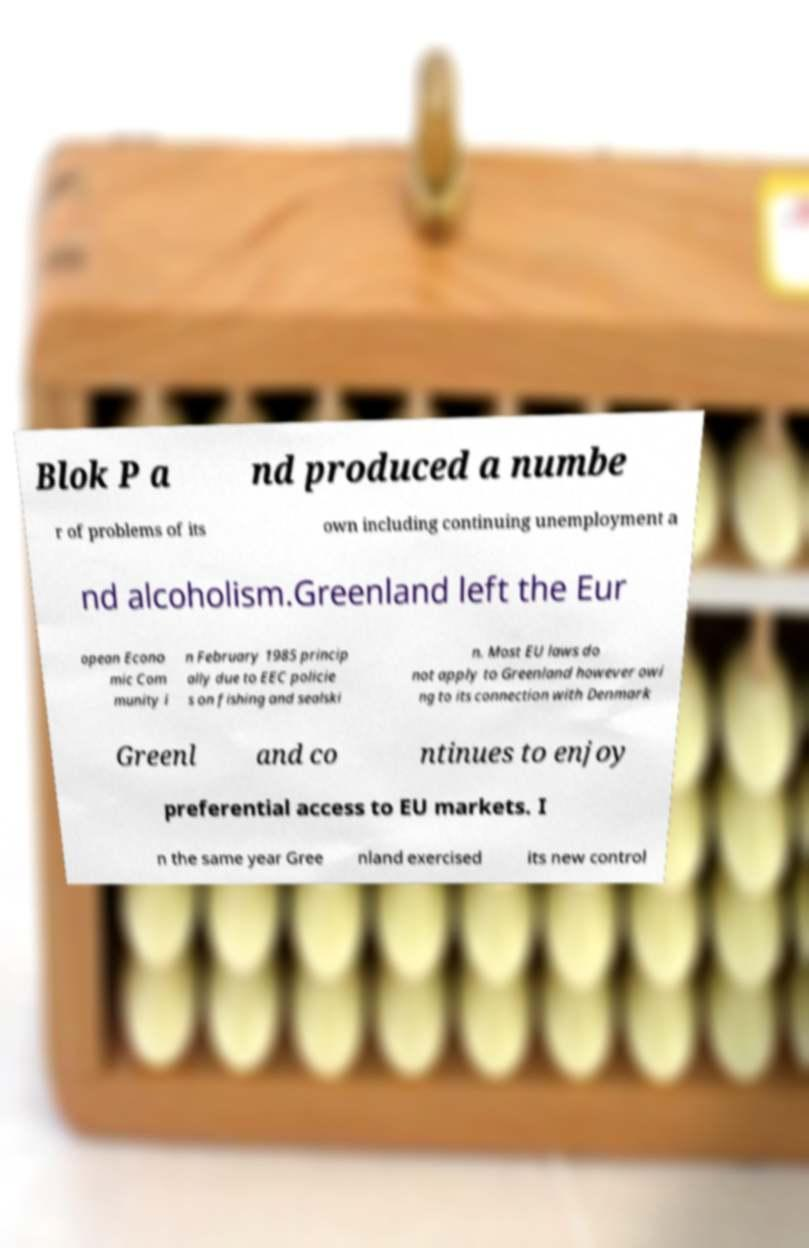I need the written content from this picture converted into text. Can you do that? Blok P a nd produced a numbe r of problems of its own including continuing unemployment a nd alcoholism.Greenland left the Eur opean Econo mic Com munity i n February 1985 princip ally due to EEC policie s on fishing and sealski n. Most EU laws do not apply to Greenland however owi ng to its connection with Denmark Greenl and co ntinues to enjoy preferential access to EU markets. I n the same year Gree nland exercised its new control 